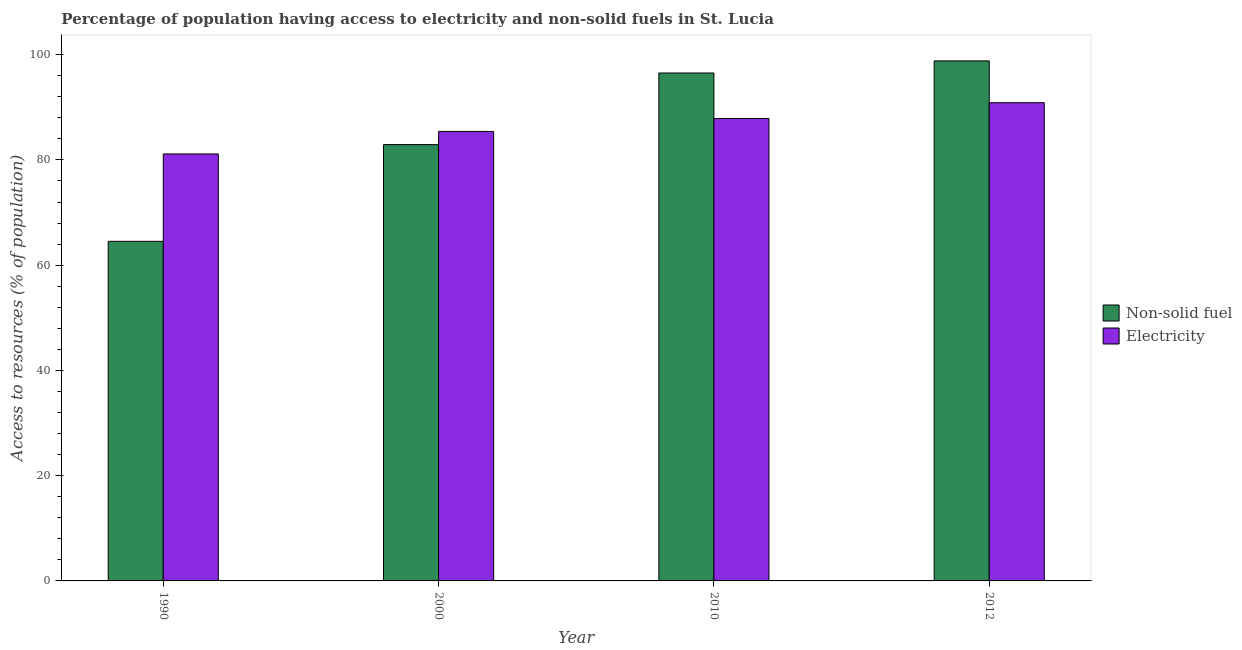How many different coloured bars are there?
Give a very brief answer. 2. Are the number of bars per tick equal to the number of legend labels?
Your response must be concise. Yes. How many bars are there on the 2nd tick from the left?
Give a very brief answer. 2. How many bars are there on the 4th tick from the right?
Your answer should be compact. 2. What is the percentage of population having access to electricity in 1990?
Your answer should be compact. 81.14. Across all years, what is the maximum percentage of population having access to non-solid fuel?
Offer a very short reply. 98.82. Across all years, what is the minimum percentage of population having access to non-solid fuel?
Your answer should be very brief. 64.53. In which year was the percentage of population having access to electricity minimum?
Offer a very short reply. 1990. What is the total percentage of population having access to non-solid fuel in the graph?
Offer a very short reply. 342.78. What is the difference between the percentage of population having access to electricity in 1990 and that in 2012?
Ensure brevity in your answer.  -9.74. What is the difference between the percentage of population having access to electricity in 2012 and the percentage of population having access to non-solid fuel in 2010?
Your response must be concise. 3. What is the average percentage of population having access to non-solid fuel per year?
Ensure brevity in your answer.  85.7. In the year 2010, what is the difference between the percentage of population having access to electricity and percentage of population having access to non-solid fuel?
Ensure brevity in your answer.  0. In how many years, is the percentage of population having access to non-solid fuel greater than 4 %?
Your response must be concise. 4. What is the ratio of the percentage of population having access to electricity in 2010 to that in 2012?
Make the answer very short. 0.97. Is the difference between the percentage of population having access to electricity in 2000 and 2012 greater than the difference between the percentage of population having access to non-solid fuel in 2000 and 2012?
Make the answer very short. No. What is the difference between the highest and the second highest percentage of population having access to electricity?
Ensure brevity in your answer.  3. What is the difference between the highest and the lowest percentage of population having access to electricity?
Your answer should be very brief. 9.74. In how many years, is the percentage of population having access to electricity greater than the average percentage of population having access to electricity taken over all years?
Your response must be concise. 2. Is the sum of the percentage of population having access to non-solid fuel in 2000 and 2012 greater than the maximum percentage of population having access to electricity across all years?
Your response must be concise. Yes. What does the 2nd bar from the left in 2010 represents?
Give a very brief answer. Electricity. What does the 1st bar from the right in 2010 represents?
Your answer should be very brief. Electricity. What is the difference between two consecutive major ticks on the Y-axis?
Give a very brief answer. 20. Are the values on the major ticks of Y-axis written in scientific E-notation?
Provide a succinct answer. No. Does the graph contain grids?
Offer a very short reply. No. Where does the legend appear in the graph?
Keep it short and to the point. Center right. How many legend labels are there?
Your answer should be compact. 2. What is the title of the graph?
Your response must be concise. Percentage of population having access to electricity and non-solid fuels in St. Lucia. Does "Not attending school" appear as one of the legend labels in the graph?
Provide a short and direct response. No. What is the label or title of the Y-axis?
Provide a succinct answer. Access to resources (% of population). What is the Access to resources (% of population) in Non-solid fuel in 1990?
Your answer should be very brief. 64.53. What is the Access to resources (% of population) in Electricity in 1990?
Provide a succinct answer. 81.14. What is the Access to resources (% of population) in Non-solid fuel in 2000?
Keep it short and to the point. 82.91. What is the Access to resources (% of population) in Electricity in 2000?
Provide a succinct answer. 85.41. What is the Access to resources (% of population) of Non-solid fuel in 2010?
Give a very brief answer. 96.52. What is the Access to resources (% of population) of Electricity in 2010?
Provide a succinct answer. 87.87. What is the Access to resources (% of population) in Non-solid fuel in 2012?
Ensure brevity in your answer.  98.82. What is the Access to resources (% of population) in Electricity in 2012?
Provide a short and direct response. 90.88. Across all years, what is the maximum Access to resources (% of population) of Non-solid fuel?
Ensure brevity in your answer.  98.82. Across all years, what is the maximum Access to resources (% of population) of Electricity?
Ensure brevity in your answer.  90.88. Across all years, what is the minimum Access to resources (% of population) of Non-solid fuel?
Give a very brief answer. 64.53. Across all years, what is the minimum Access to resources (% of population) of Electricity?
Offer a very short reply. 81.14. What is the total Access to resources (% of population) of Non-solid fuel in the graph?
Offer a very short reply. 342.78. What is the total Access to resources (% of population) in Electricity in the graph?
Provide a succinct answer. 345.3. What is the difference between the Access to resources (% of population) in Non-solid fuel in 1990 and that in 2000?
Your answer should be very brief. -18.38. What is the difference between the Access to resources (% of population) in Electricity in 1990 and that in 2000?
Your answer should be compact. -4.28. What is the difference between the Access to resources (% of population) in Non-solid fuel in 1990 and that in 2010?
Ensure brevity in your answer.  -31.99. What is the difference between the Access to resources (% of population) in Electricity in 1990 and that in 2010?
Offer a terse response. -6.74. What is the difference between the Access to resources (% of population) of Non-solid fuel in 1990 and that in 2012?
Give a very brief answer. -34.29. What is the difference between the Access to resources (% of population) of Electricity in 1990 and that in 2012?
Make the answer very short. -9.74. What is the difference between the Access to resources (% of population) in Non-solid fuel in 2000 and that in 2010?
Offer a very short reply. -13.61. What is the difference between the Access to resources (% of population) in Electricity in 2000 and that in 2010?
Your answer should be very brief. -2.46. What is the difference between the Access to resources (% of population) of Non-solid fuel in 2000 and that in 2012?
Your answer should be compact. -15.91. What is the difference between the Access to resources (% of population) in Electricity in 2000 and that in 2012?
Keep it short and to the point. -5.46. What is the difference between the Access to resources (% of population) of Non-solid fuel in 2010 and that in 2012?
Your answer should be compact. -2.3. What is the difference between the Access to resources (% of population) in Electricity in 2010 and that in 2012?
Offer a terse response. -3. What is the difference between the Access to resources (% of population) of Non-solid fuel in 1990 and the Access to resources (% of population) of Electricity in 2000?
Keep it short and to the point. -20.88. What is the difference between the Access to resources (% of population) in Non-solid fuel in 1990 and the Access to resources (% of population) in Electricity in 2010?
Your response must be concise. -23.34. What is the difference between the Access to resources (% of population) of Non-solid fuel in 1990 and the Access to resources (% of population) of Electricity in 2012?
Give a very brief answer. -26.34. What is the difference between the Access to resources (% of population) in Non-solid fuel in 2000 and the Access to resources (% of population) in Electricity in 2010?
Provide a short and direct response. -4.96. What is the difference between the Access to resources (% of population) of Non-solid fuel in 2000 and the Access to resources (% of population) of Electricity in 2012?
Give a very brief answer. -7.97. What is the difference between the Access to resources (% of population) in Non-solid fuel in 2010 and the Access to resources (% of population) in Electricity in 2012?
Ensure brevity in your answer.  5.64. What is the average Access to resources (% of population) in Non-solid fuel per year?
Provide a succinct answer. 85.7. What is the average Access to resources (% of population) in Electricity per year?
Provide a succinct answer. 86.32. In the year 1990, what is the difference between the Access to resources (% of population) of Non-solid fuel and Access to resources (% of population) of Electricity?
Your answer should be very brief. -16.6. In the year 2000, what is the difference between the Access to resources (% of population) in Non-solid fuel and Access to resources (% of population) in Electricity?
Keep it short and to the point. -2.5. In the year 2010, what is the difference between the Access to resources (% of population) in Non-solid fuel and Access to resources (% of population) in Electricity?
Ensure brevity in your answer.  8.65. In the year 2012, what is the difference between the Access to resources (% of population) in Non-solid fuel and Access to resources (% of population) in Electricity?
Make the answer very short. 7.95. What is the ratio of the Access to resources (% of population) in Non-solid fuel in 1990 to that in 2000?
Offer a terse response. 0.78. What is the ratio of the Access to resources (% of population) of Electricity in 1990 to that in 2000?
Your answer should be very brief. 0.95. What is the ratio of the Access to resources (% of population) in Non-solid fuel in 1990 to that in 2010?
Keep it short and to the point. 0.67. What is the ratio of the Access to resources (% of population) in Electricity in 1990 to that in 2010?
Offer a terse response. 0.92. What is the ratio of the Access to resources (% of population) in Non-solid fuel in 1990 to that in 2012?
Your response must be concise. 0.65. What is the ratio of the Access to resources (% of population) of Electricity in 1990 to that in 2012?
Offer a terse response. 0.89. What is the ratio of the Access to resources (% of population) of Non-solid fuel in 2000 to that in 2010?
Make the answer very short. 0.86. What is the ratio of the Access to resources (% of population) in Electricity in 2000 to that in 2010?
Your answer should be compact. 0.97. What is the ratio of the Access to resources (% of population) in Non-solid fuel in 2000 to that in 2012?
Your answer should be very brief. 0.84. What is the ratio of the Access to resources (% of population) in Electricity in 2000 to that in 2012?
Ensure brevity in your answer.  0.94. What is the ratio of the Access to resources (% of population) of Non-solid fuel in 2010 to that in 2012?
Offer a very short reply. 0.98. What is the ratio of the Access to resources (% of population) of Electricity in 2010 to that in 2012?
Make the answer very short. 0.97. What is the difference between the highest and the second highest Access to resources (% of population) of Non-solid fuel?
Offer a terse response. 2.3. What is the difference between the highest and the second highest Access to resources (% of population) in Electricity?
Your answer should be very brief. 3. What is the difference between the highest and the lowest Access to resources (% of population) of Non-solid fuel?
Provide a succinct answer. 34.29. What is the difference between the highest and the lowest Access to resources (% of population) in Electricity?
Give a very brief answer. 9.74. 